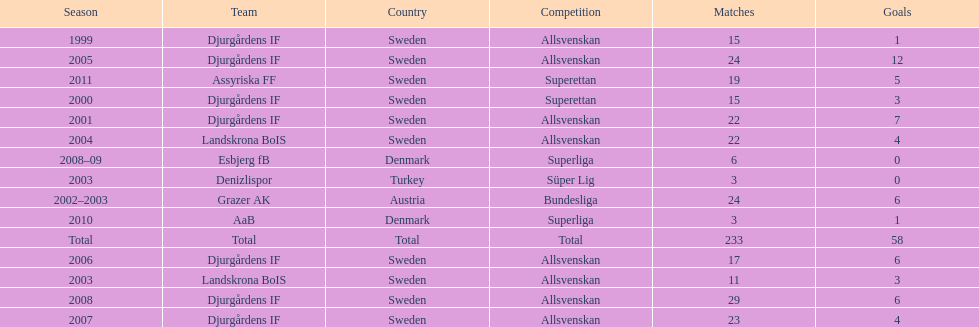What country is team djurgårdens if not from? Sweden. 